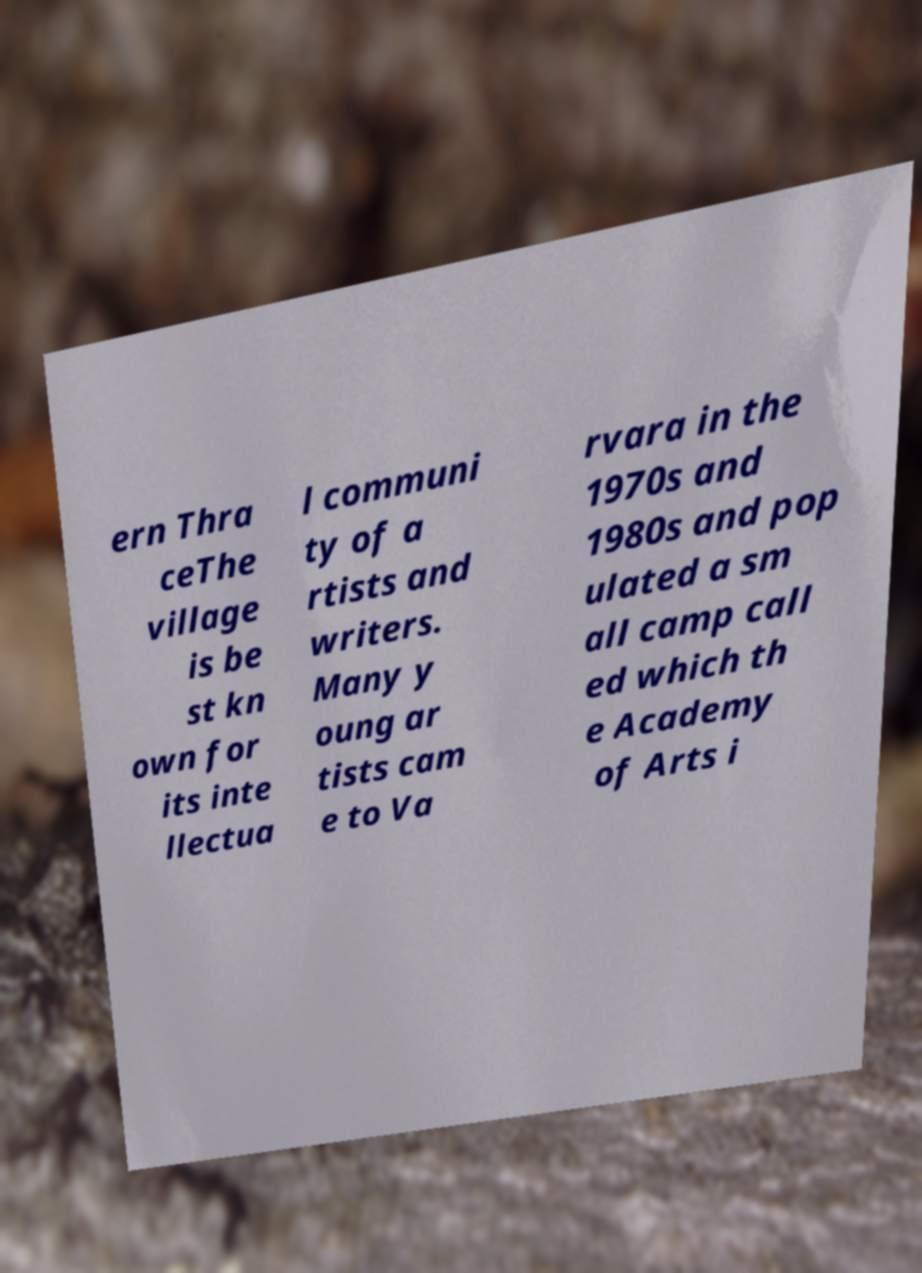Could you assist in decoding the text presented in this image and type it out clearly? ern Thra ceThe village is be st kn own for its inte llectua l communi ty of a rtists and writers. Many y oung ar tists cam e to Va rvara in the 1970s and 1980s and pop ulated a sm all camp call ed which th e Academy of Arts i 